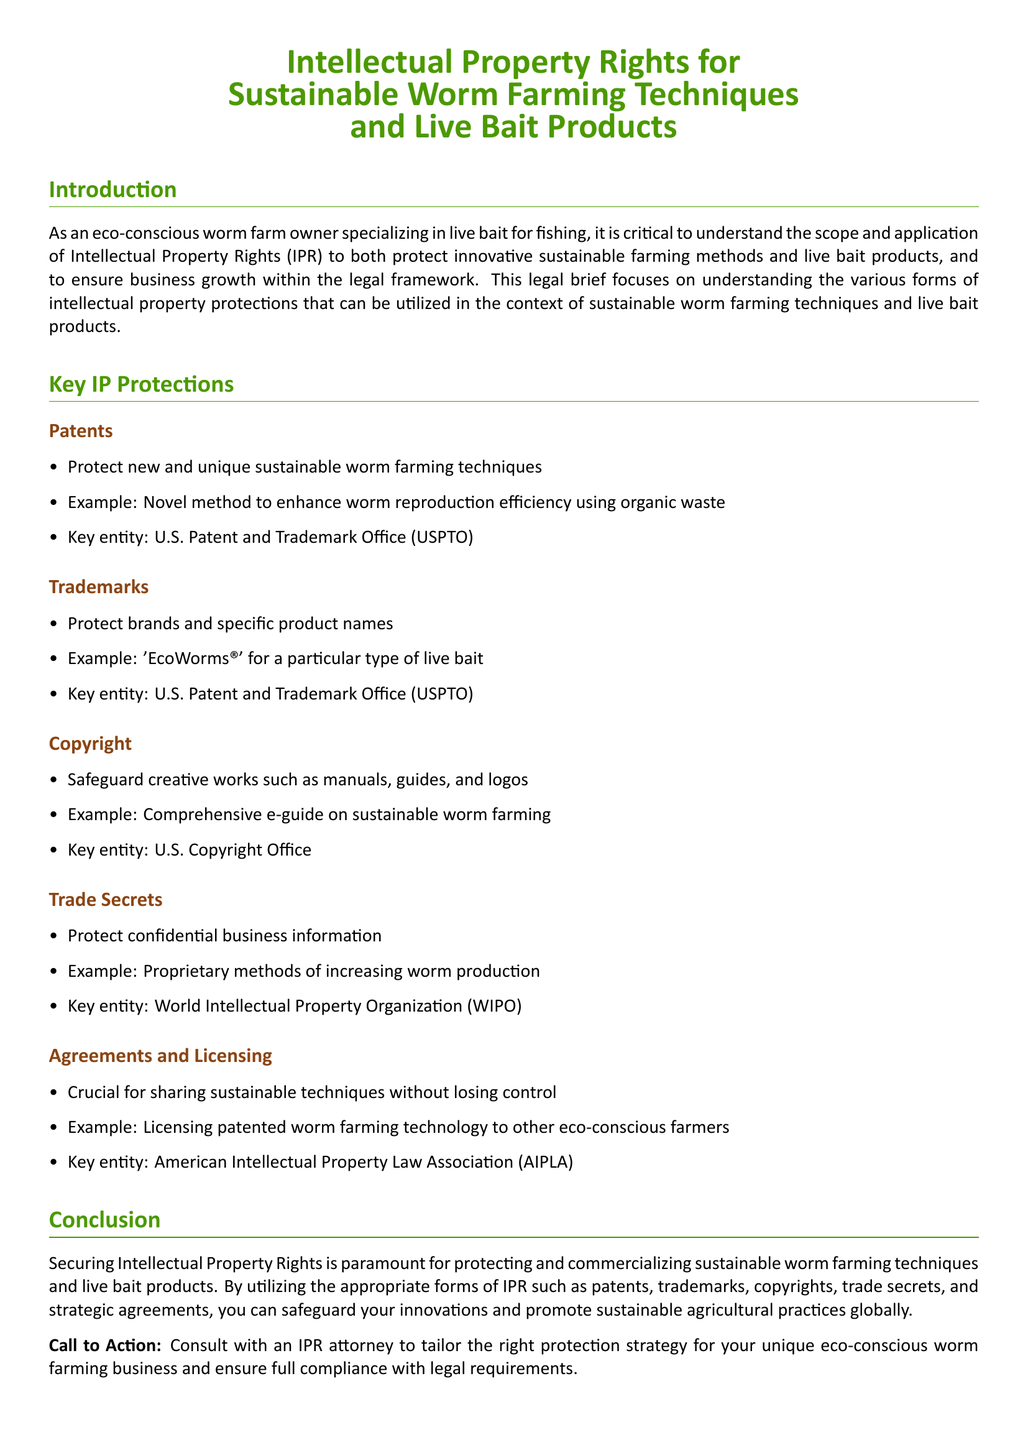What is the main focus of the legal brief? The legal brief focuses on understanding the various forms of intellectual property protections that can be utilized in the context of sustainable worm farming techniques and live bait products.
Answer: Intellectual property rights What is an example of a patent mentioned in the document? The document provides an example of a novel method to enhance worm reproduction efficiency using organic waste as a patentable innovation.
Answer: Novel method to enhance worm reproduction efficiency using organic waste Which entity is responsible for trademarks? The document states the U.S. Patent and Trademark Office (USPTO) as the key entity responsible for trademarks related to sustainable worm farming.
Answer: U.S. Patent and Trademark Office (USPTO) What type of creative work does copyright protect? The document lists manuals, guides, and logos as types of creative works that copyright protects.
Answer: Manuals, guides, and logos What is a key benefit of trade secrets according to the document? The document explains that trade secrets protect confidential business information, which can be vital for maintaining competitive advantage.
Answer: Protect confidential business information What should a business owner do to ensure full compliance with legal requirements? The conclusion recommends consulting with an IPR attorney to tailor the right protection strategy for the unique eco-conscious worm farming business.
Answer: Consult with an IPR attorney Name an example of a trademark mentioned in the brief. The document mentions 'EcoWorms®' as a trademark example for a particular type of live bait.
Answer: 'EcoWorms®' What is the purpose of strategic agreements according to the brief? The brief states that strategic agreements are crucial for sharing sustainable techniques without losing control over them.
Answer: Sharing sustainable techniques without losing control 